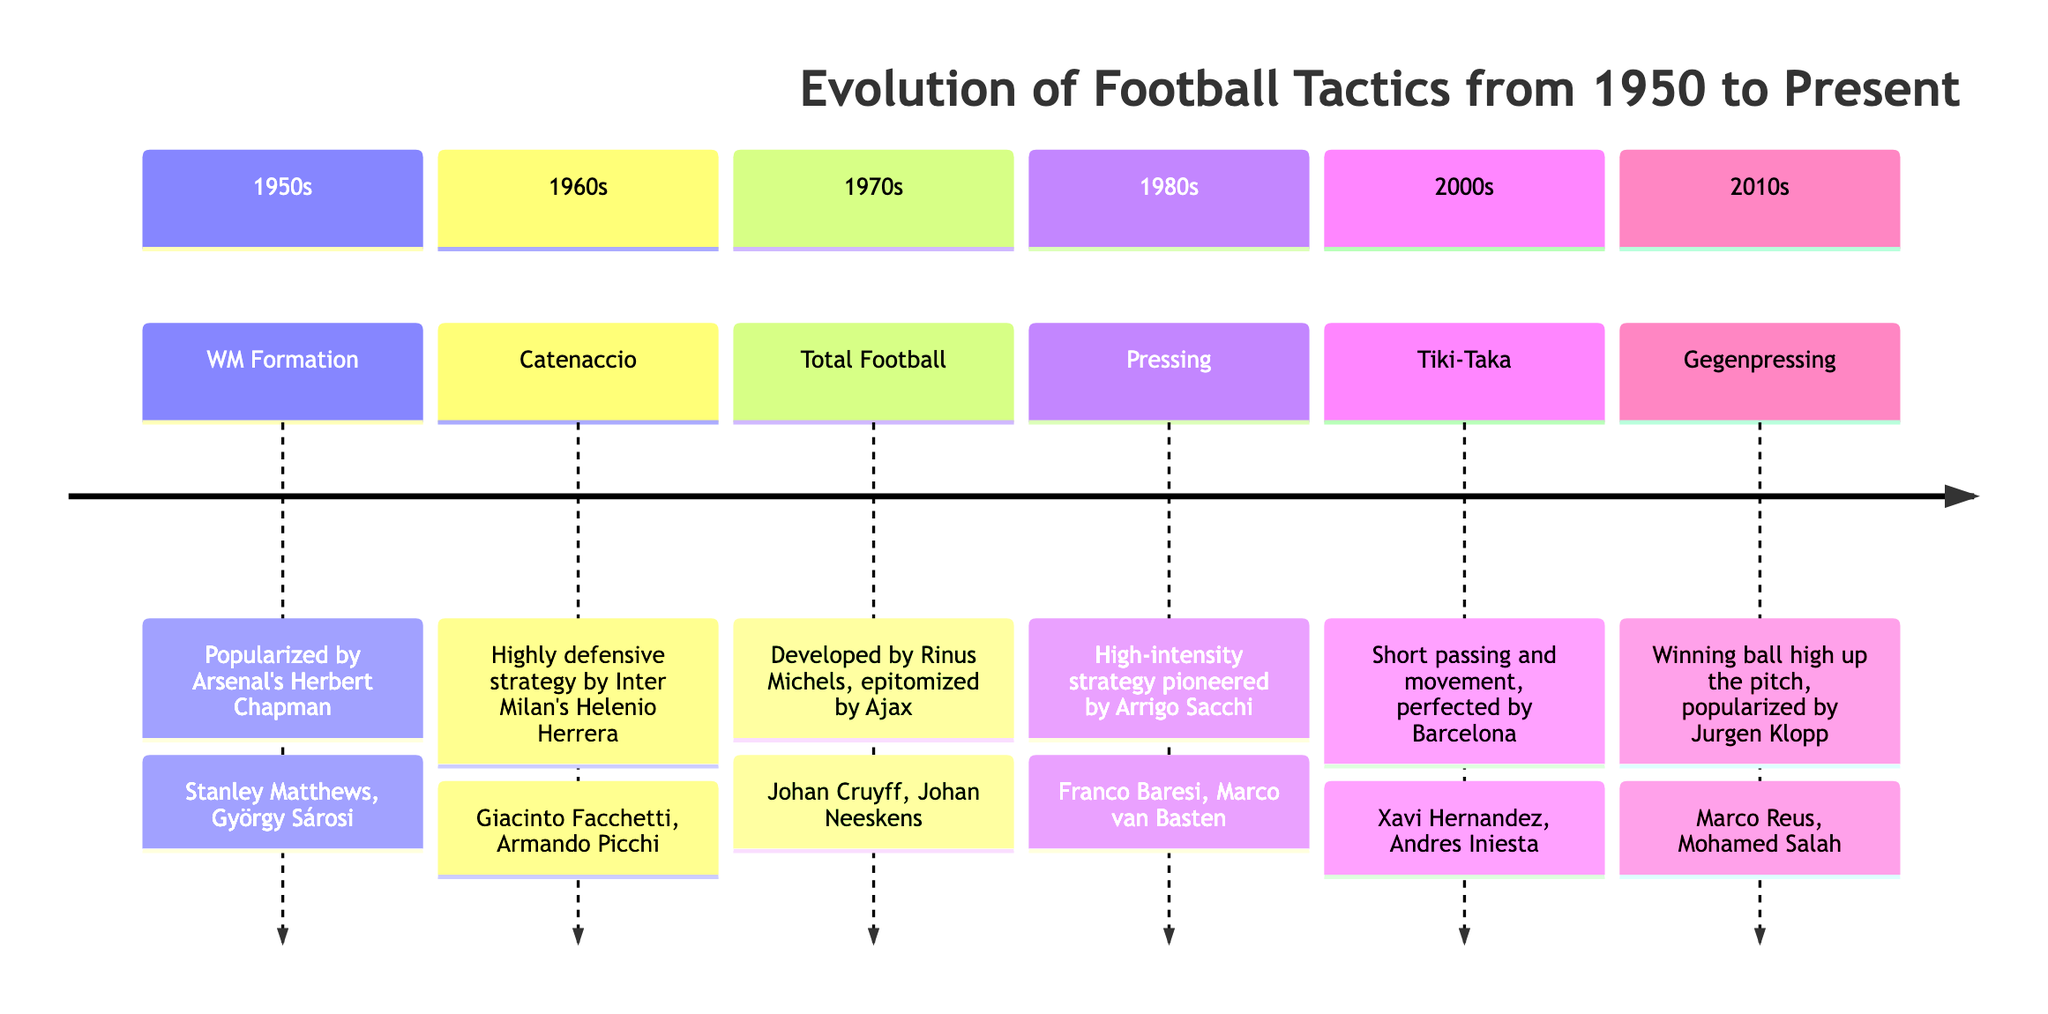What formation was popularized in the 1950s? The 1950s section of the diagram lists "WM Formation" as the tactic used during that time, indicating its popularity.
Answer: WM Formation Who was a key player of the Catenaccio tactic? The diagram notes "Giacinto Facchetti" as a key player associated with the Catenaccio tactic in the 1960s.
Answer: Giacinto Facchetti Which tactical approach involved short passing and movement? The 2000s section specifies "Tiki-Taka" developed by Barcelona emphasizing short passing and movement.
Answer: Tiki-Taka What decade did Gegenpressing become popular? The diagram indicates that Gegenpressing was popularized in the 2010s, providing clear timing for this tactic's emergence.
Answer: 2010s Name one key player from the Total Football era. According to the 1970s section, "Johan Cruyff" is noted as a key player reflecting this tactical approach.
Answer: Johan Cruyff Which tactic is associated with Jurgen Klopp? The diagram links "Gegenpressing" with Jurgen Klopp, establishing this connection in the 2010s section.
Answer: Gegenpressing How many tactics are listed in the diagram? By counting each of the tactics from the various decades presented, there are six distinct tactics shown in the timeline.
Answer: 6 What was a defining feature of the Pressing strategy? The diagram describes Pressing in the 1980s as a "High-intensity strategy," emphasizing its aggressive nature.
Answer: High-intensity Which formation was known for its defensive approach? The 1960s section highlights "Catenaccio" as a highly defensive strategy, confirming its primary characteristic.
Answer: Catenaccio 